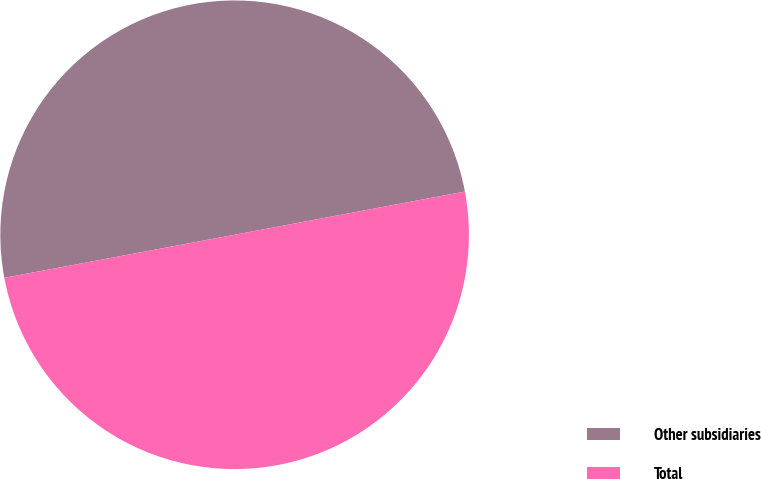<chart> <loc_0><loc_0><loc_500><loc_500><pie_chart><fcel>Other subsidiaries<fcel>Total<nl><fcel>49.99%<fcel>50.01%<nl></chart> 